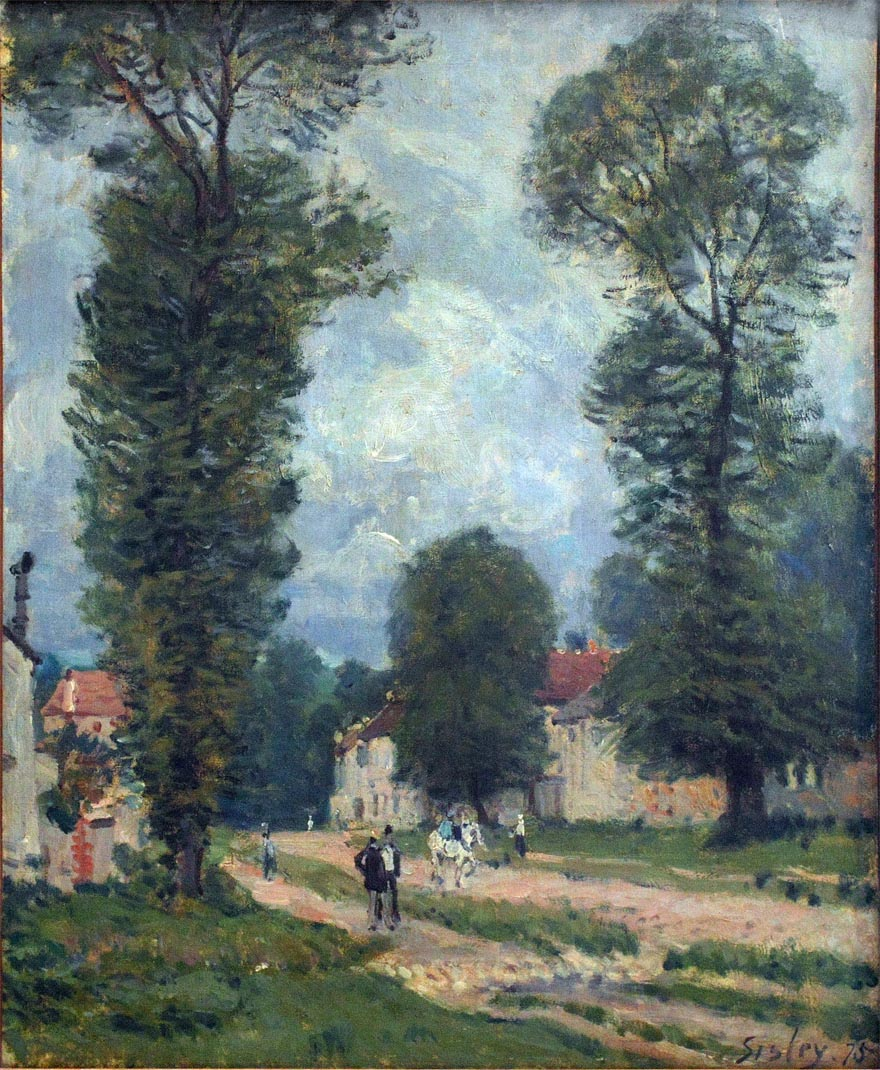What does the sky tell us about the weather? The sky in the painting, with its pale blue hue and scattered wispy clouds, suggests a clear and calm weather day. It conveys a serene and mild atmosphere, with no imminent threat of rain or storm. This peaceful sky enhances the overall tranquil mood of the painting, reflecting a typical, pleasant day in the countryside. Is it possible this painting was made at a specific time of day? Yes, it is quite possible that this painting captures a specific time of day, likely either late morning or early afternoon. The lighting is soft and even, without the elongated shadows of early morning or late evening. Additionally, the activity along the road suggests that it is a time when people are out and about, going about their daily routines. The calm and gentle sky further supports this timeframe, indicating a period of the day when the weather is at its most pleasant. 